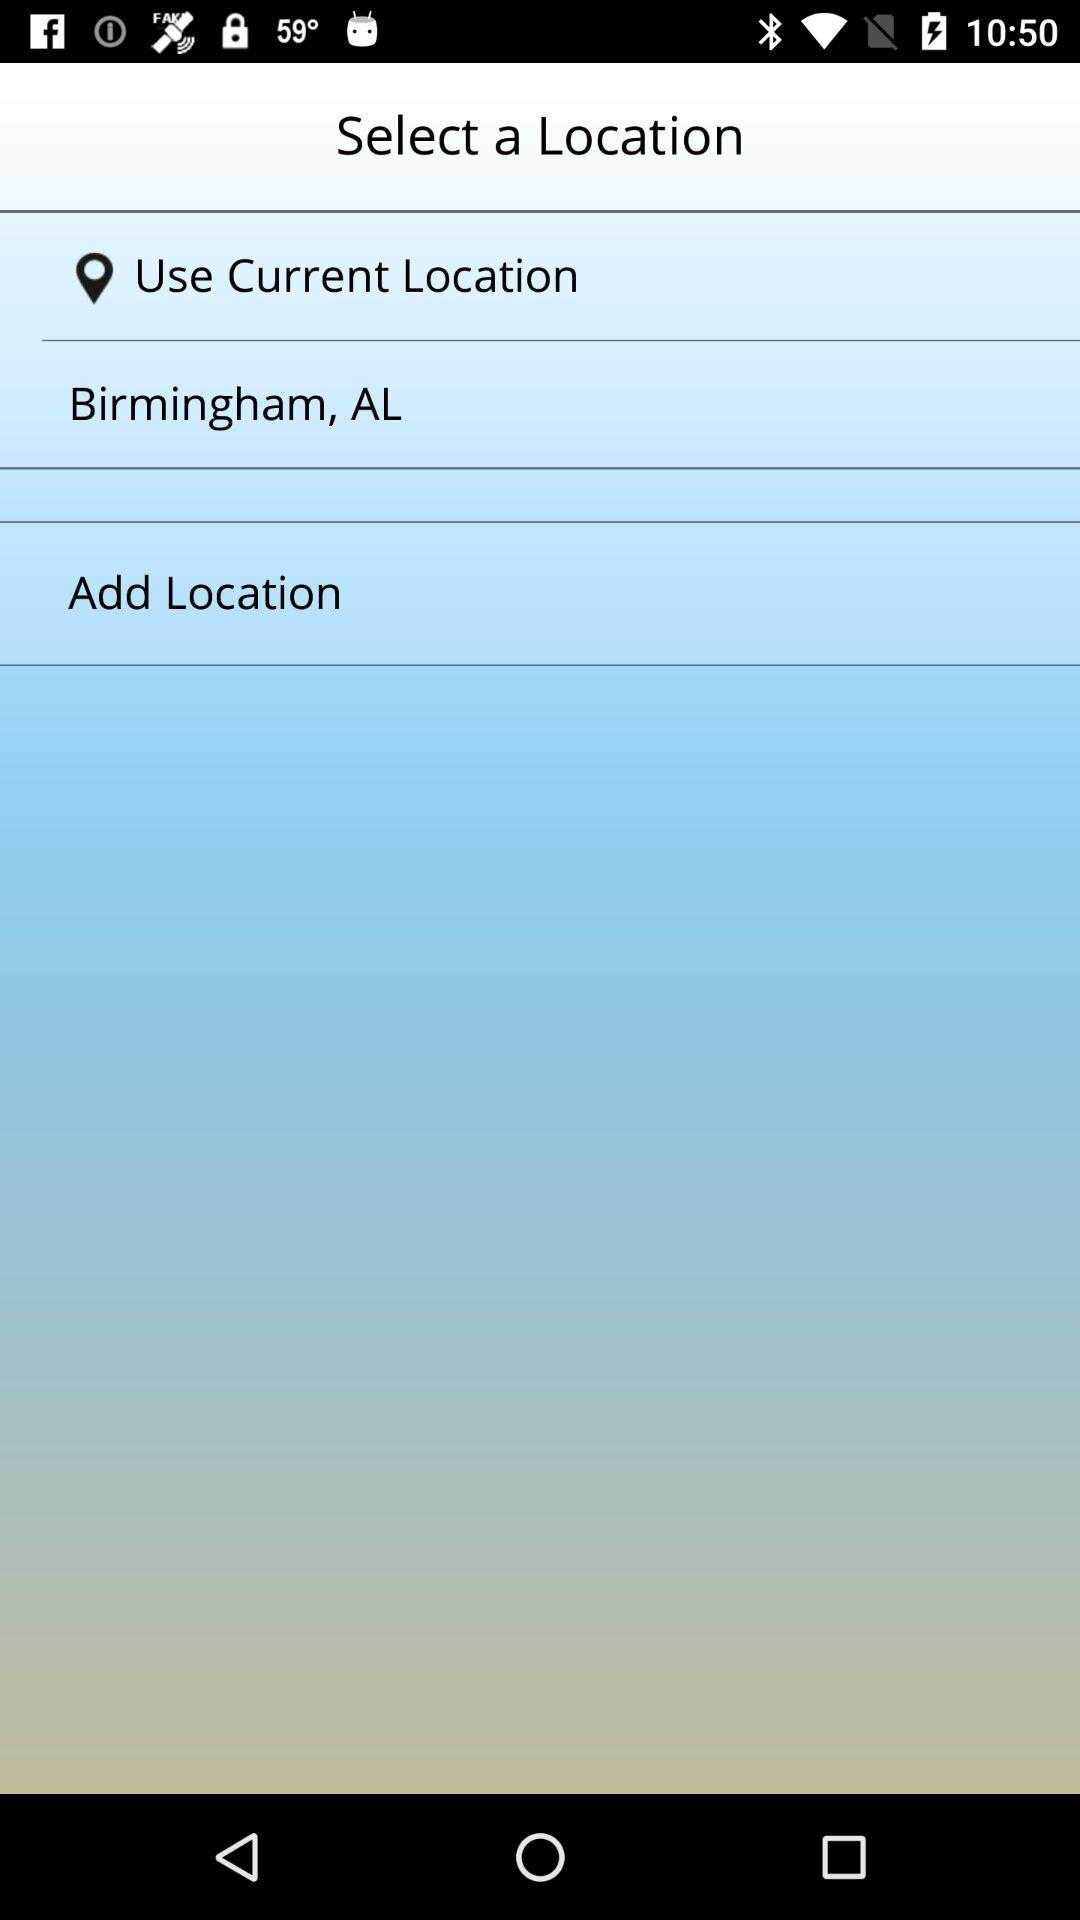What is the mentioned location? The mentioned location is Birmingham, AL. 